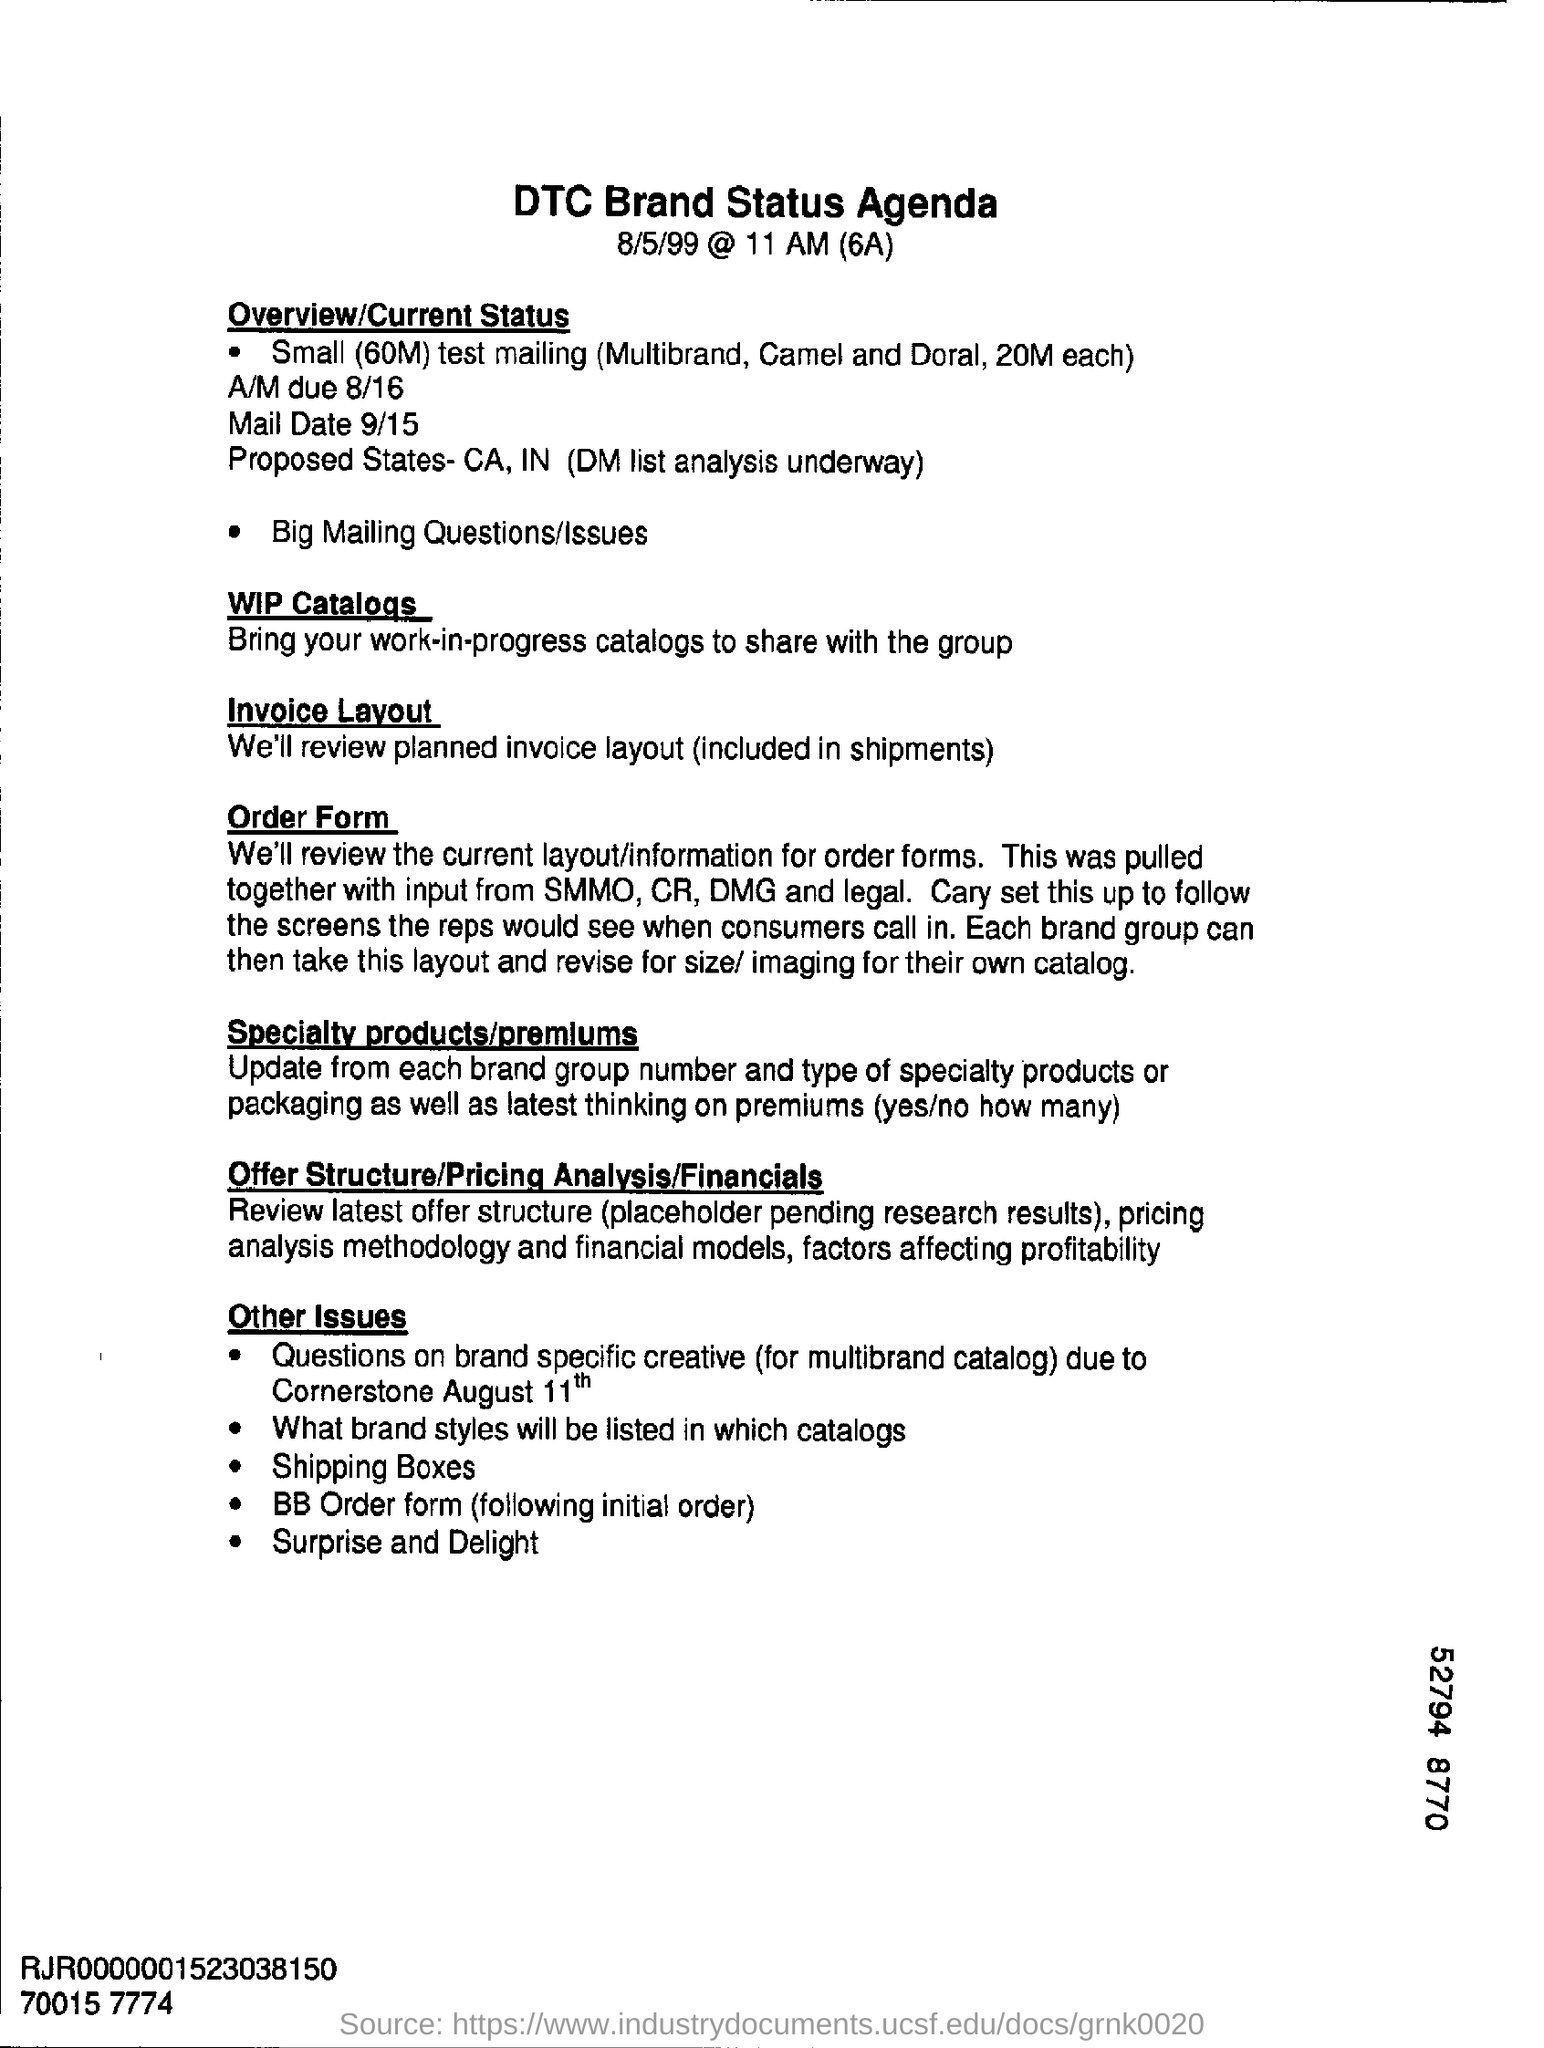Indicate a few pertinent items in this graphic. The current layout for order forms was created through a collaborative effort involving the SMMO, CR, DMG, and legal team. This document pertains to the status of DTC brand, including its agenda. 